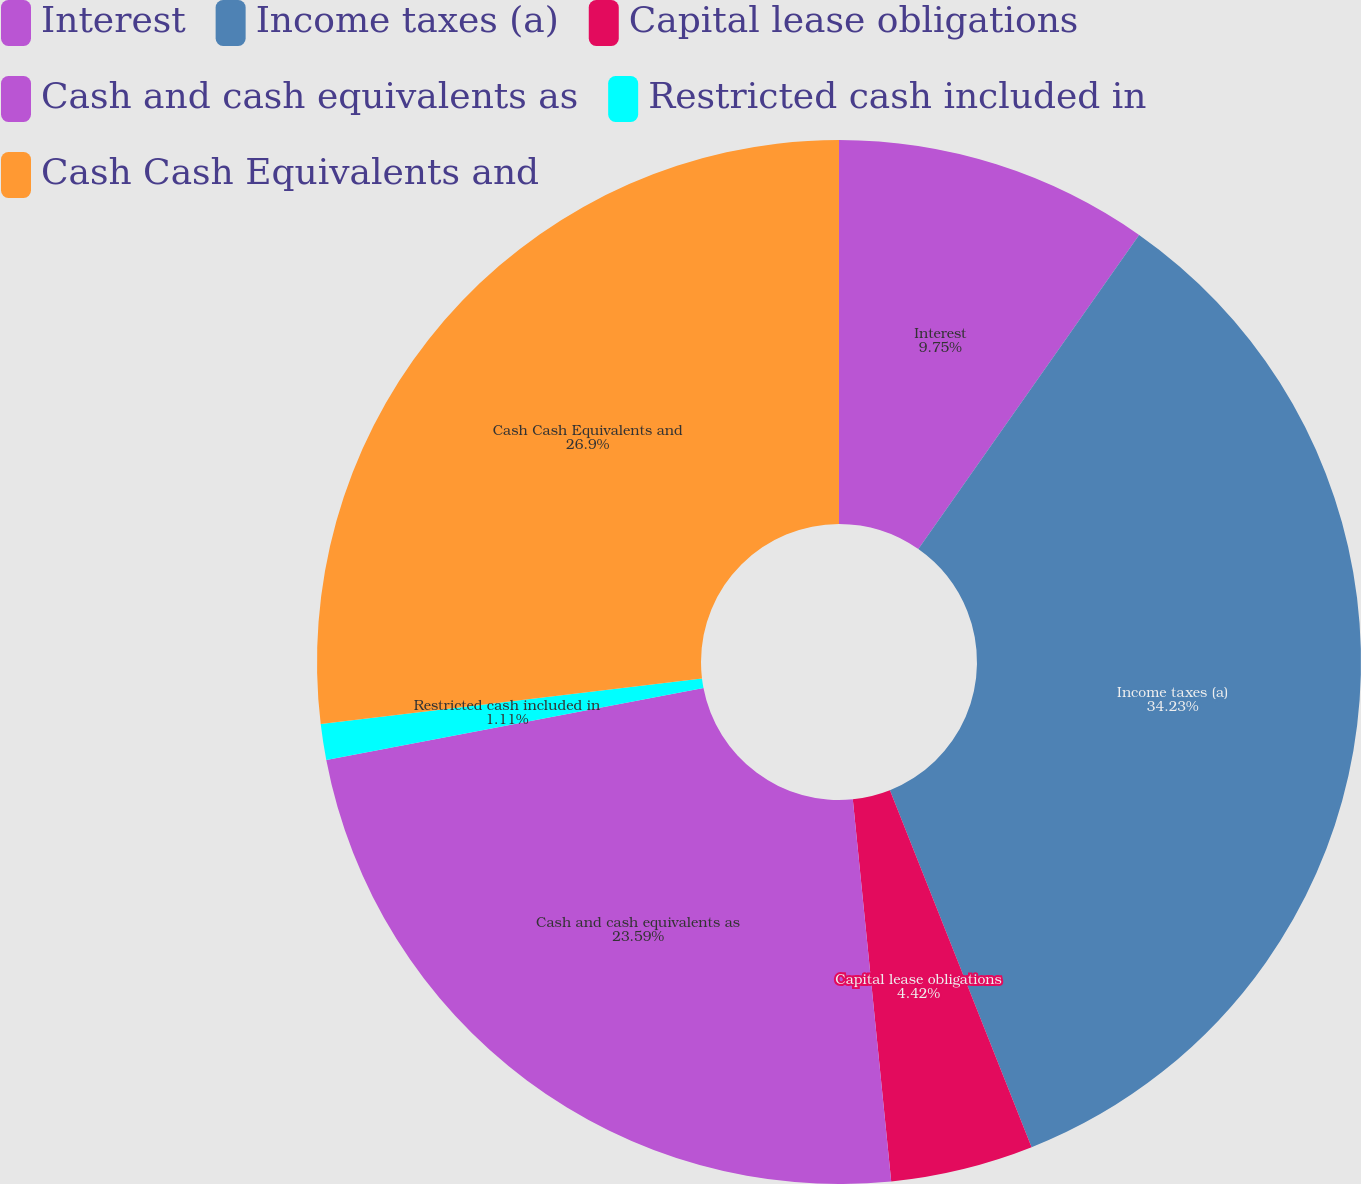Convert chart to OTSL. <chart><loc_0><loc_0><loc_500><loc_500><pie_chart><fcel>Interest<fcel>Income taxes (a)<fcel>Capital lease obligations<fcel>Cash and cash equivalents as<fcel>Restricted cash included in<fcel>Cash Cash Equivalents and<nl><fcel>9.75%<fcel>34.24%<fcel>4.42%<fcel>23.59%<fcel>1.11%<fcel>26.9%<nl></chart> 